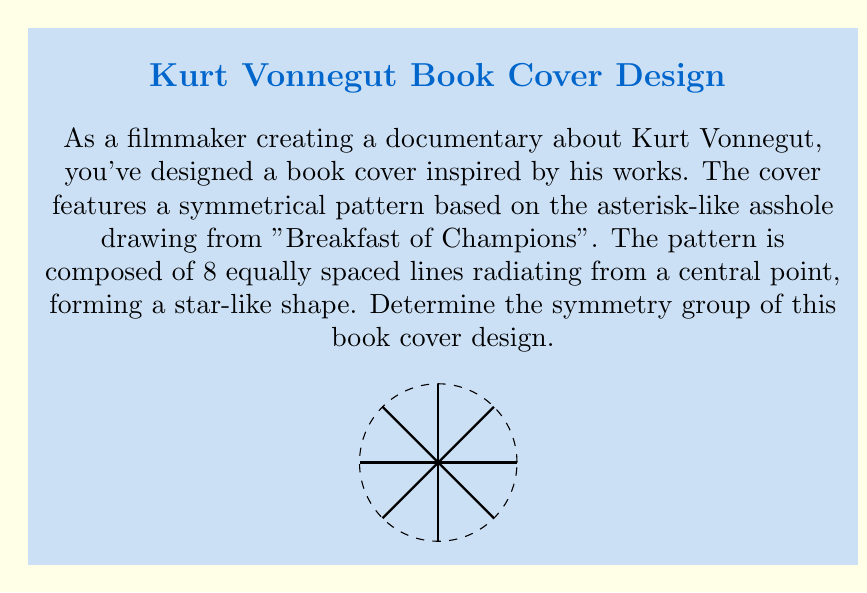What is the answer to this math problem? To determine the symmetry group of the book cover design, we need to identify all the symmetry operations that leave the pattern unchanged. Let's analyze step-by-step:

1) Rotational symmetry:
   The pattern remains unchanged when rotated by multiples of 45° (π/4 radians) around the center.
   There are 8 distinct rotations: 0°, 45°, 90°, 135°, 180°, 225°, 270°, and 315°.

2) Reflection symmetry:
   The pattern has 8 lines of reflection:
   - 4 lines passing through opposite rays
   - 4 lines bisecting the angles between adjacent rays

3) Identity transformation:
   The pattern remains unchanged when no transformation is applied (rotation by 0° or 360°).

The symmetry group of this pattern is known as the dihedral group of order 16, denoted as $D_8$ or $D_{16}$ (depending on the notation system).

The group elements are:
- 8 rotations (including identity): $r_0, r_1, r_2, r_3, r_4, r_5, r_6, r_7$
  where $r_k$ represents a rotation by $k * 45°$
- 8 reflections: $s_0, s_1, s_2, s_3, s_4, s_5, s_6, s_7$
  where $s_k$ represents a reflection across the $k$-th line of symmetry

The group operation table would be 16x16, combining these 16 elements.

Properties of $D_8$:
1) Order of the group: $|D_8| = 16$
2) Abelian: No (rotations and reflections don't always commute)
3) Generators: Can be generated by a rotation of 45° and any reflection

This symmetry group captures the artistic essence of Vonnegut's simple yet profound illustrations, mirroring the balance between complexity and simplicity in his literary works.
Answer: $D_8$ (or $D_{16}$) 